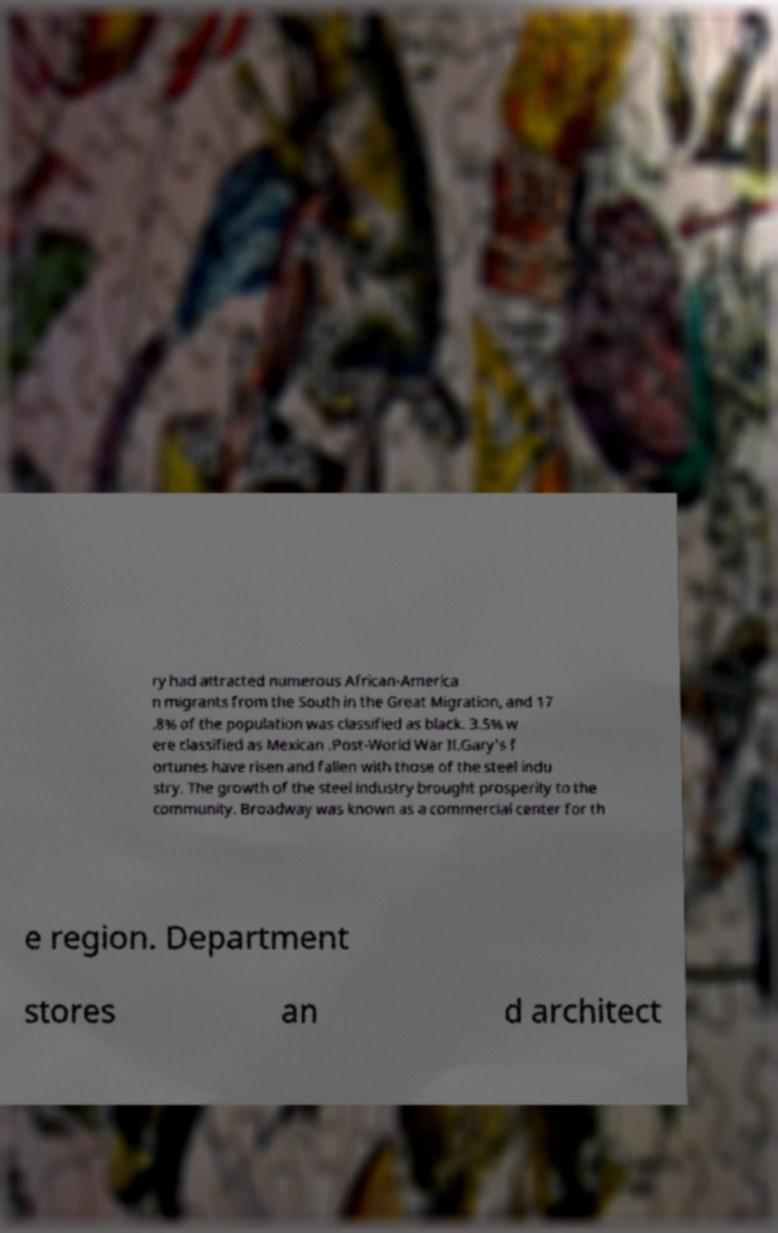I need the written content from this picture converted into text. Can you do that? ry had attracted numerous African-America n migrants from the South in the Great Migration, and 17 .8% of the population was classified as black. 3.5% w ere classified as Mexican .Post-World War II.Gary's f ortunes have risen and fallen with those of the steel indu stry. The growth of the steel industry brought prosperity to the community. Broadway was known as a commercial center for th e region. Department stores an d architect 